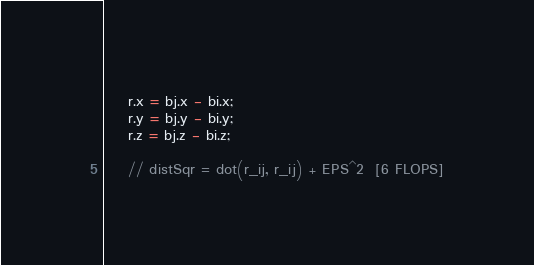<code> <loc_0><loc_0><loc_500><loc_500><_Cuda_>    r.x = bj.x - bi.x;
    r.y = bj.y - bi.y;
    r.z = bj.z - bi.z;

    // distSqr = dot(r_ij, r_ij) + EPS^2  [6 FLOPS]</code> 